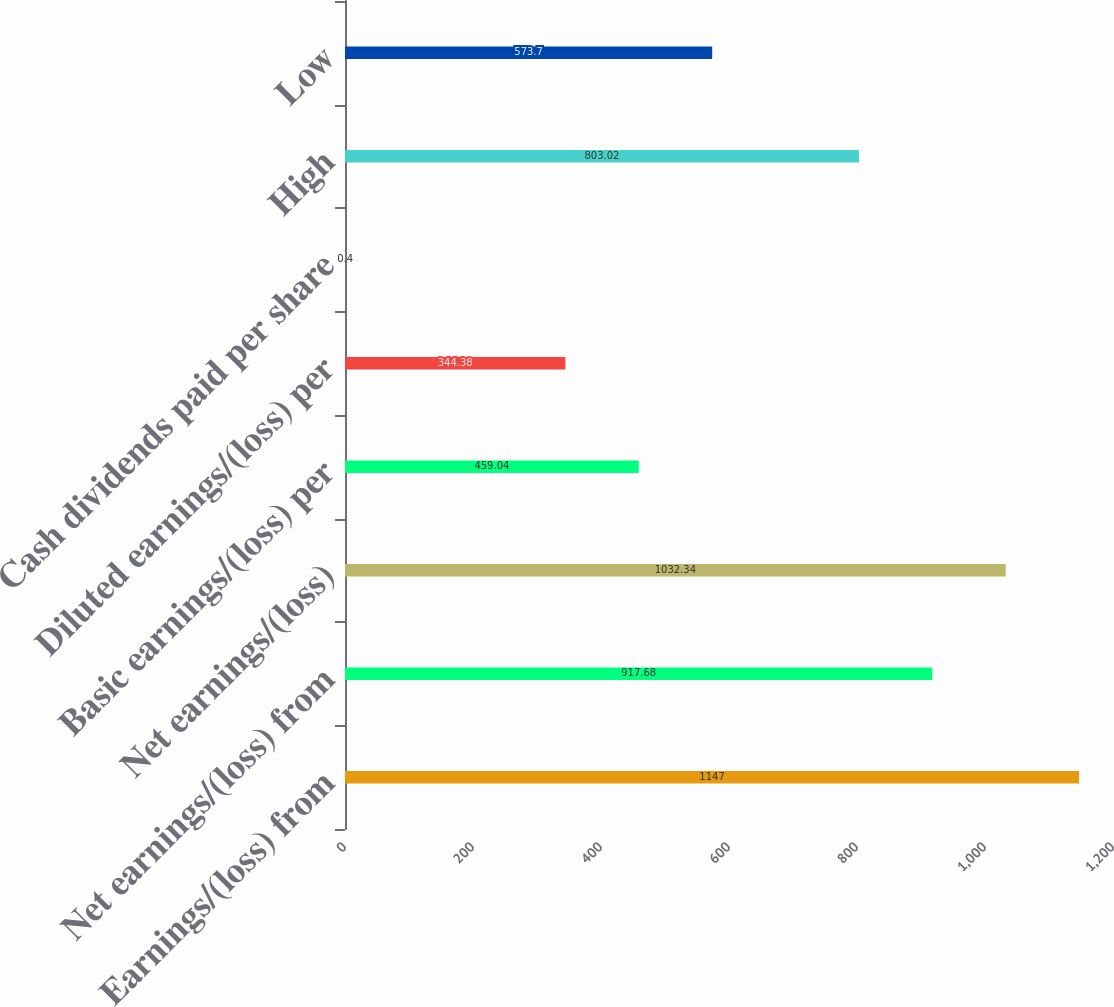<chart> <loc_0><loc_0><loc_500><loc_500><bar_chart><fcel>Earnings/(loss) from<fcel>Net earnings/(loss) from<fcel>Net earnings/(loss)<fcel>Basic earnings/(loss) per<fcel>Diluted earnings/(loss) per<fcel>Cash dividends paid per share<fcel>High<fcel>Low<nl><fcel>1147<fcel>917.68<fcel>1032.34<fcel>459.04<fcel>344.38<fcel>0.4<fcel>803.02<fcel>573.7<nl></chart> 